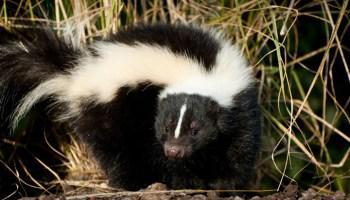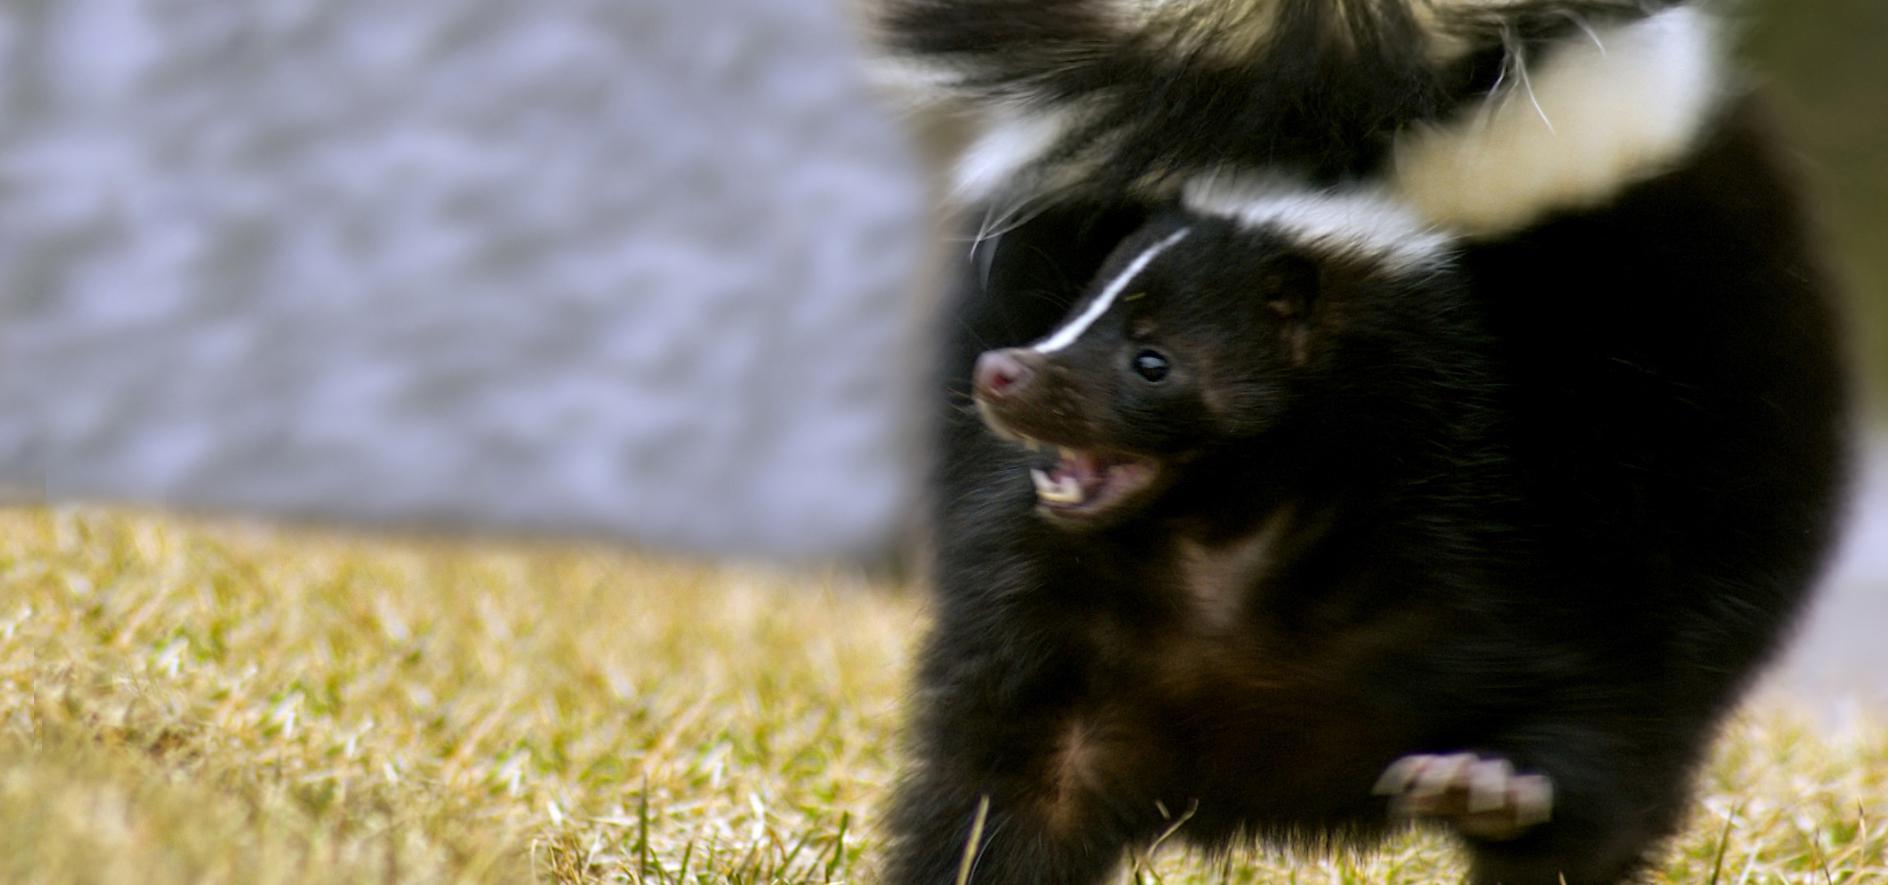The first image is the image on the left, the second image is the image on the right. For the images shown, is this caption "There is one skunk in one image, and more than one skunk in the other image." true? Answer yes or no. No. The first image is the image on the left, the second image is the image on the right. Considering the images on both sides, is "There are exactly two skunks." valid? Answer yes or no. Yes. 